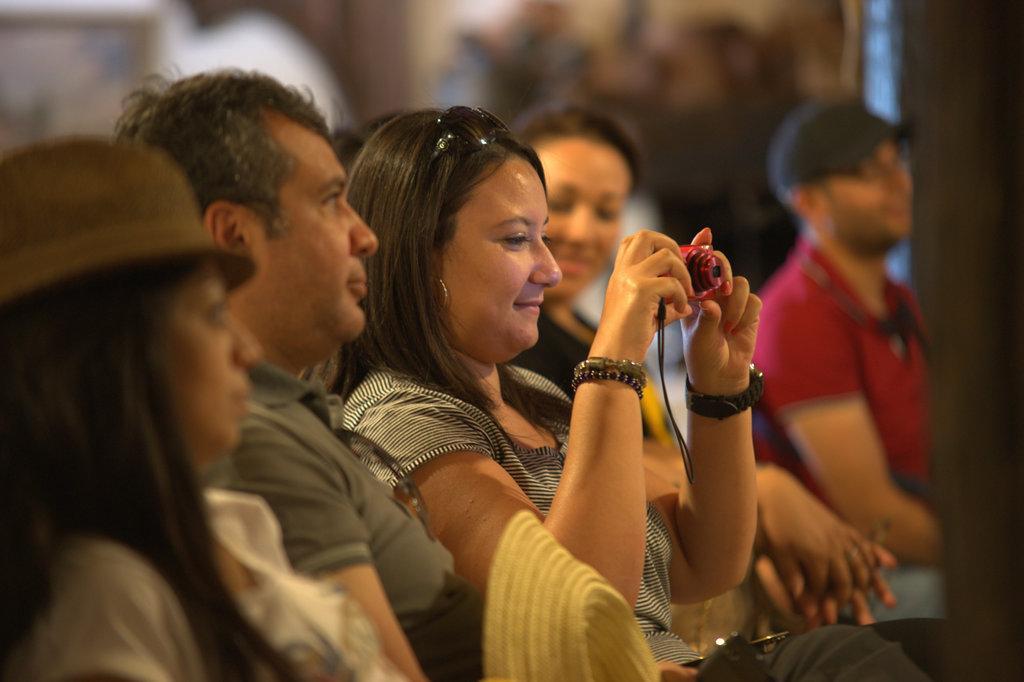Please provide a concise description of this image. In this picture I can see there are few people sitting here and there is a woman sitting here and she is holding a camera and clicking pictures and in the backdrop I can see there is a wall. 